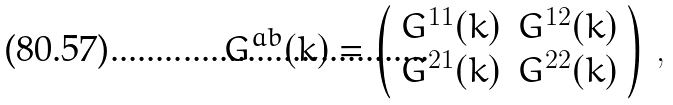Convert formula to latex. <formula><loc_0><loc_0><loc_500><loc_500>G ^ { a b } ( k ) = \left ( \begin{array} { l l } { { G ^ { 1 1 } ( k ) } } & { { G ^ { 1 2 } ( k ) } } \\ { { G ^ { 2 1 } ( k ) } } & { { G ^ { 2 2 } ( k ) } } \end{array} \right ) \, ,</formula> 